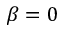Convert formula to latex. <formula><loc_0><loc_0><loc_500><loc_500>\beta = 0</formula> 